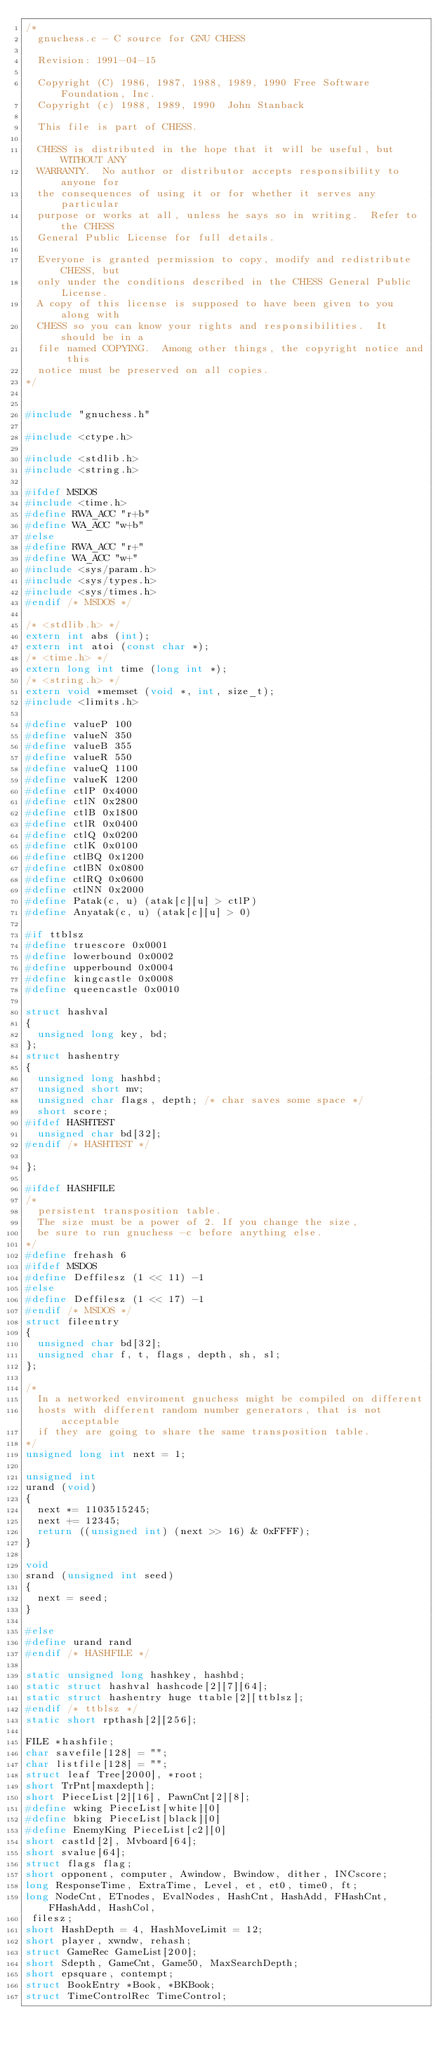<code> <loc_0><loc_0><loc_500><loc_500><_C_>/*
  gnuchess.c - C source for GNU CHESS

  Revision: 1991-04-15

  Copyright (C) 1986, 1987, 1988, 1989, 1990 Free Software Foundation, Inc.
  Copyright (c) 1988, 1989, 1990  John Stanback

  This file is part of CHESS.

  CHESS is distributed in the hope that it will be useful, but WITHOUT ANY
  WARRANTY.  No author or distributor accepts responsibility to anyone for
  the consequences of using it or for whether it serves any particular
  purpose or works at all, unless he says so in writing.  Refer to the CHESS
  General Public License for full details.

  Everyone is granted permission to copy, modify and redistribute CHESS, but
  only under the conditions described in the CHESS General Public License.
  A copy of this license is supposed to have been given to you along with
  CHESS so you can know your rights and responsibilities.  It should be in a
  file named COPYING.  Among other things, the copyright notice and this
  notice must be preserved on all copies.
*/


#include "gnuchess.h"

#include <ctype.h>

#include <stdlib.h>
#include <string.h>

#ifdef MSDOS
#include <time.h>
#define RWA_ACC "r+b"
#define WA_ACC "w+b"
#else
#define RWA_ACC "r+"
#define WA_ACC "w+"
#include <sys/param.h>
#include <sys/types.h>
#include <sys/times.h>
#endif /* MSDOS */

/* <stdlib.h> */
extern int abs (int);
extern int atoi (const char *);
/* <time.h> */
extern long int time (long int *);
/* <string.h> */
extern void *memset (void *, int, size_t);
#include <limits.h>

#define valueP 100
#define valueN 350
#define valueB 355
#define valueR 550
#define valueQ 1100
#define valueK 1200
#define ctlP 0x4000
#define ctlN 0x2800
#define ctlB 0x1800
#define ctlR 0x0400
#define ctlQ 0x0200
#define ctlK 0x0100
#define ctlBQ 0x1200
#define ctlBN 0x0800
#define ctlRQ 0x0600
#define ctlNN 0x2000
#define Patak(c, u) (atak[c][u] > ctlP)
#define Anyatak(c, u) (atak[c][u] > 0)

#if ttblsz
#define truescore 0x0001
#define lowerbound 0x0002
#define upperbound 0x0004
#define kingcastle 0x0008
#define queencastle 0x0010

struct hashval
{
  unsigned long key, bd;
};
struct hashentry
{
  unsigned long hashbd;
  unsigned short mv;
  unsigned char flags, depth;	/* char saves some space */
  short score;
#ifdef HASHTEST
  unsigned char bd[32];
#endif /* HASHTEST */

};

#ifdef HASHFILE
/*
  persistent transposition table.
  The size must be a power of 2. If you change the size,
  be sure to run gnuchess -c before anything else.
*/
#define frehash 6
#ifdef MSDOS
#define Deffilesz (1 << 11) -1
#else
#define Deffilesz (1 << 17) -1
#endif /* MSDOS */
struct fileentry
{
  unsigned char bd[32];
  unsigned char f, t, flags, depth, sh, sl;
};

/*
  In a networked enviroment gnuchess might be compiled on different
  hosts with different random number generators, that is not acceptable
  if they are going to share the same transposition table.
*/
unsigned long int next = 1;

unsigned int
urand (void)
{
  next *= 1103515245;
  next += 12345;
  return ((unsigned int) (next >> 16) & 0xFFFF);
}

void
srand (unsigned int seed)
{
  next = seed;
}

#else
#define urand rand
#endif /* HASHFILE */

static unsigned long hashkey, hashbd;
static struct hashval hashcode[2][7][64];
static struct hashentry huge ttable[2][ttblsz];
#endif /* ttblsz */
static short rpthash[2][256];

FILE *hashfile;
char savefile[128] = "";
char listfile[128] = "";
struct leaf Tree[2000], *root;
short TrPnt[maxdepth];
short PieceList[2][16], PawnCnt[2][8];
#define wking PieceList[white][0]
#define bking PieceList[black][0]
#define EnemyKing PieceList[c2][0]
short castld[2], Mvboard[64];
short svalue[64];
struct flags flag;
short opponent, computer, Awindow, Bwindow, dither, INCscore;
long ResponseTime, ExtraTime, Level, et, et0, time0, ft;
long NodeCnt, ETnodes, EvalNodes, HashCnt, HashAdd, FHashCnt, FHashAdd, HashCol,
 filesz;
short HashDepth = 4, HashMoveLimit = 12;
short player, xwndw, rehash;
struct GameRec GameList[200];
short Sdepth, GameCnt, Game50, MaxSearchDepth;
short epsquare, contempt;
struct BookEntry *Book, *BKBook;
struct TimeControlRec TimeControl;</code> 